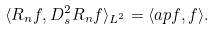Convert formula to latex. <formula><loc_0><loc_0><loc_500><loc_500>\langle R _ { n } f , D ^ { 2 } _ { s } R _ { n } f \rangle _ { L ^ { 2 } } = \langle \L a p f , f \rangle .</formula> 